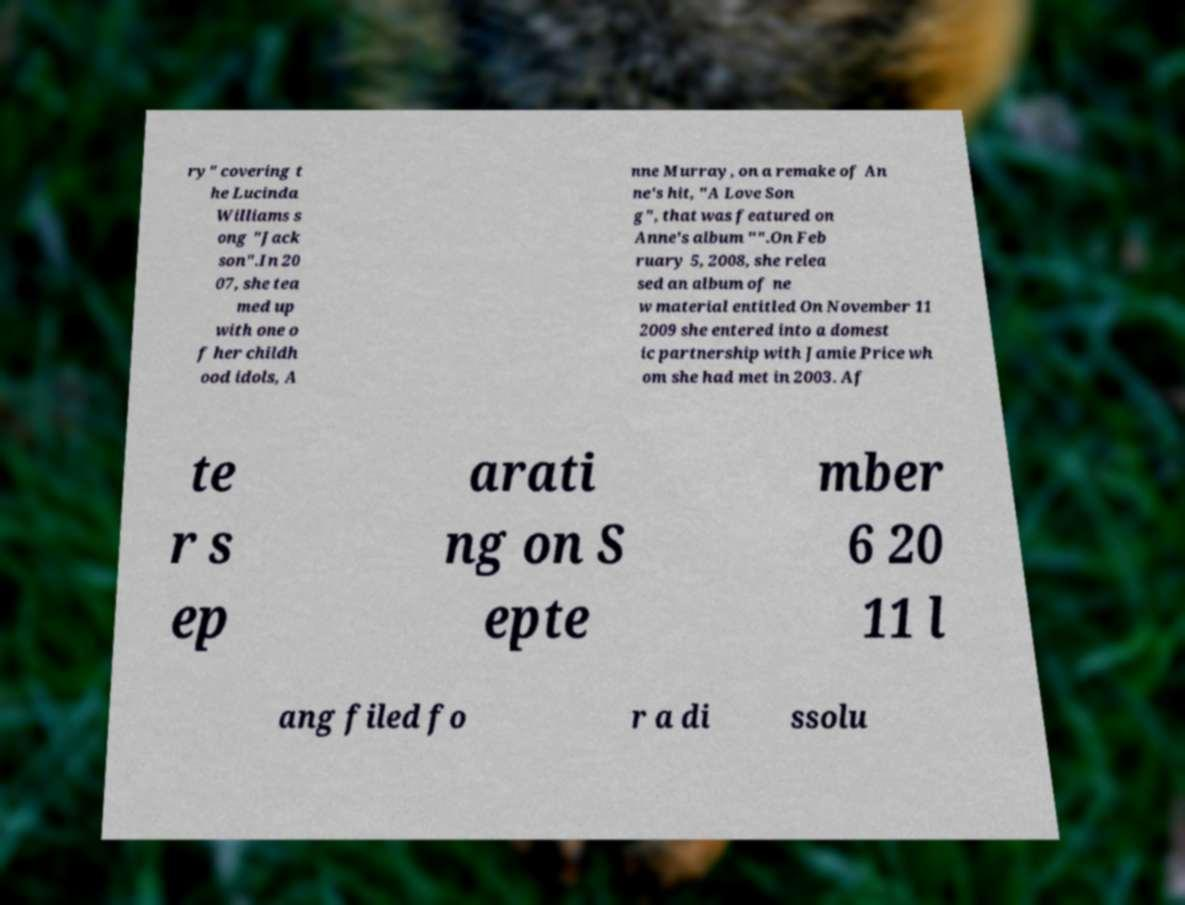Please read and relay the text visible in this image. What does it say? ry" covering t he Lucinda Williams s ong "Jack son".In 20 07, she tea med up with one o f her childh ood idols, A nne Murray, on a remake of An ne's hit, "A Love Son g", that was featured on Anne's album "".On Feb ruary 5, 2008, she relea sed an album of ne w material entitled On November 11 2009 she entered into a domest ic partnership with Jamie Price wh om she had met in 2003. Af te r s ep arati ng on S epte mber 6 20 11 l ang filed fo r a di ssolu 